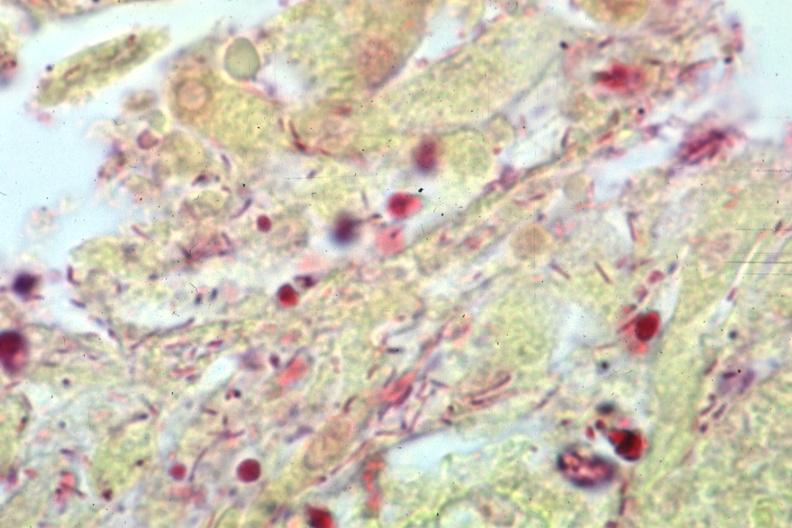s meningitis purulent present?
Answer the question using a single word or phrase. Yes 